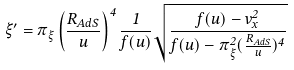<formula> <loc_0><loc_0><loc_500><loc_500>\xi ^ { \prime } = \pi _ { \xi } \left ( \frac { R _ { A d S } } { u } \right ) ^ { 4 } \frac { 1 } { f ( u ) } \sqrt { \frac { f ( u ) - v _ { x } ^ { 2 } } { f ( u ) - \pi ^ { 2 } _ { \xi } ( \frac { R _ { A d S } } { u } ) ^ { 4 } } }</formula> 